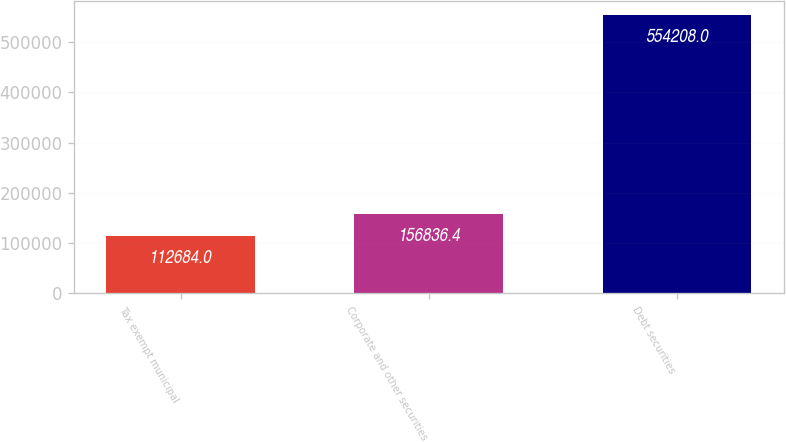<chart> <loc_0><loc_0><loc_500><loc_500><bar_chart><fcel>Tax exempt municipal<fcel>Corporate and other securities<fcel>Debt securities<nl><fcel>112684<fcel>156836<fcel>554208<nl></chart> 